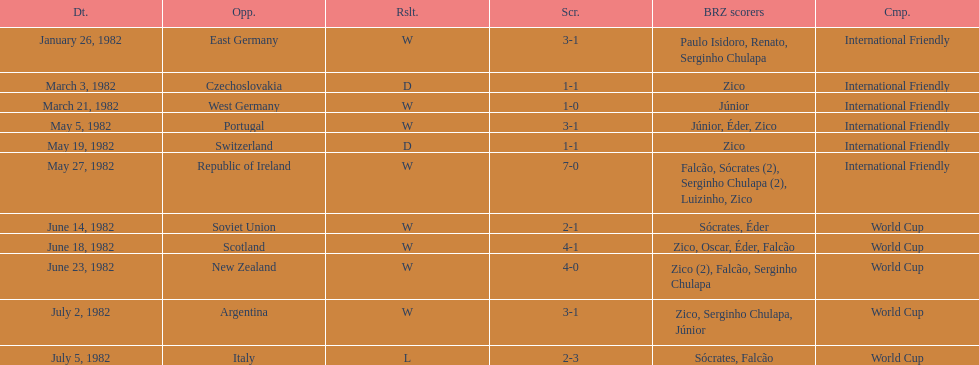How many games did zico end up scoring in during this season? 7. 